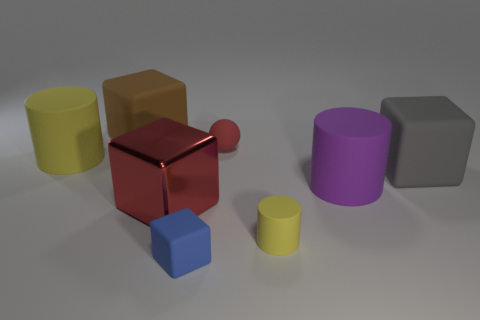What material is the large object that is on the left side of the large rubber cube that is behind the big thing to the left of the brown block? In the image, the large object to the left of the large rubber cube—which is indeed rubber based on its appearance, like a yoga block—is difficult to discern because the question is somewhat ambiguous. However, if we are looking at the object directly to the left of the red reflective cube (the largest one resembling rubber), then we are seeing a blue cube which appears to be made of the same material as the red cube, possibly also rubber or a matte plastic. 